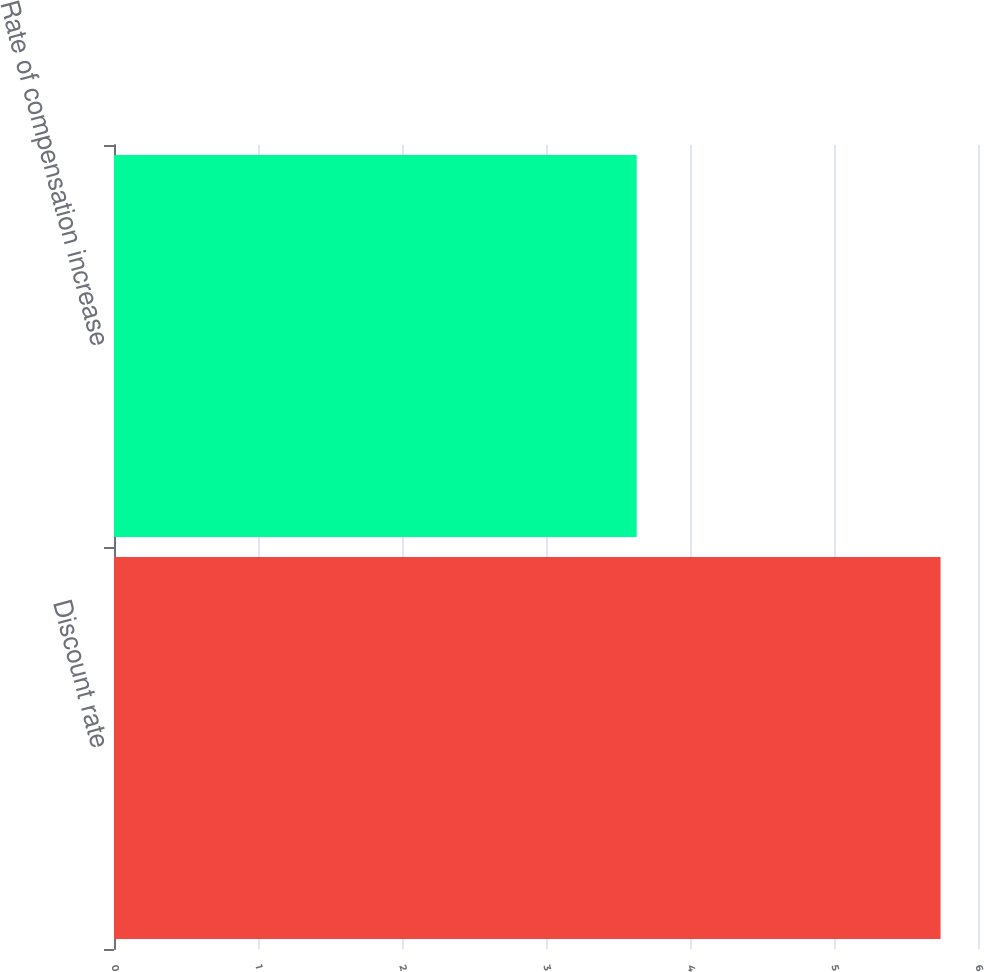Convert chart. <chart><loc_0><loc_0><loc_500><loc_500><bar_chart><fcel>Discount rate<fcel>Rate of compensation increase<nl><fcel>5.74<fcel>3.63<nl></chart> 